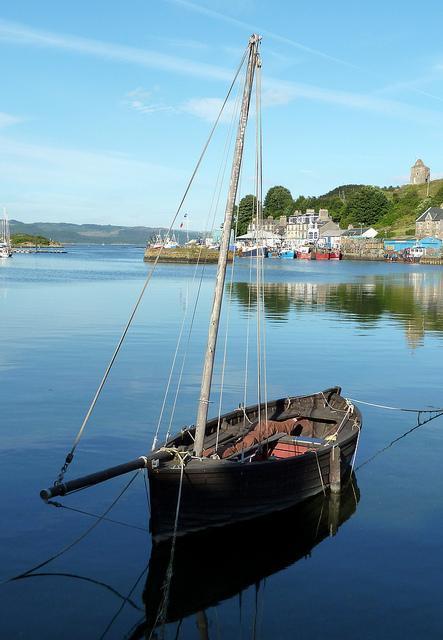How many chairs are visible?
Give a very brief answer. 0. 